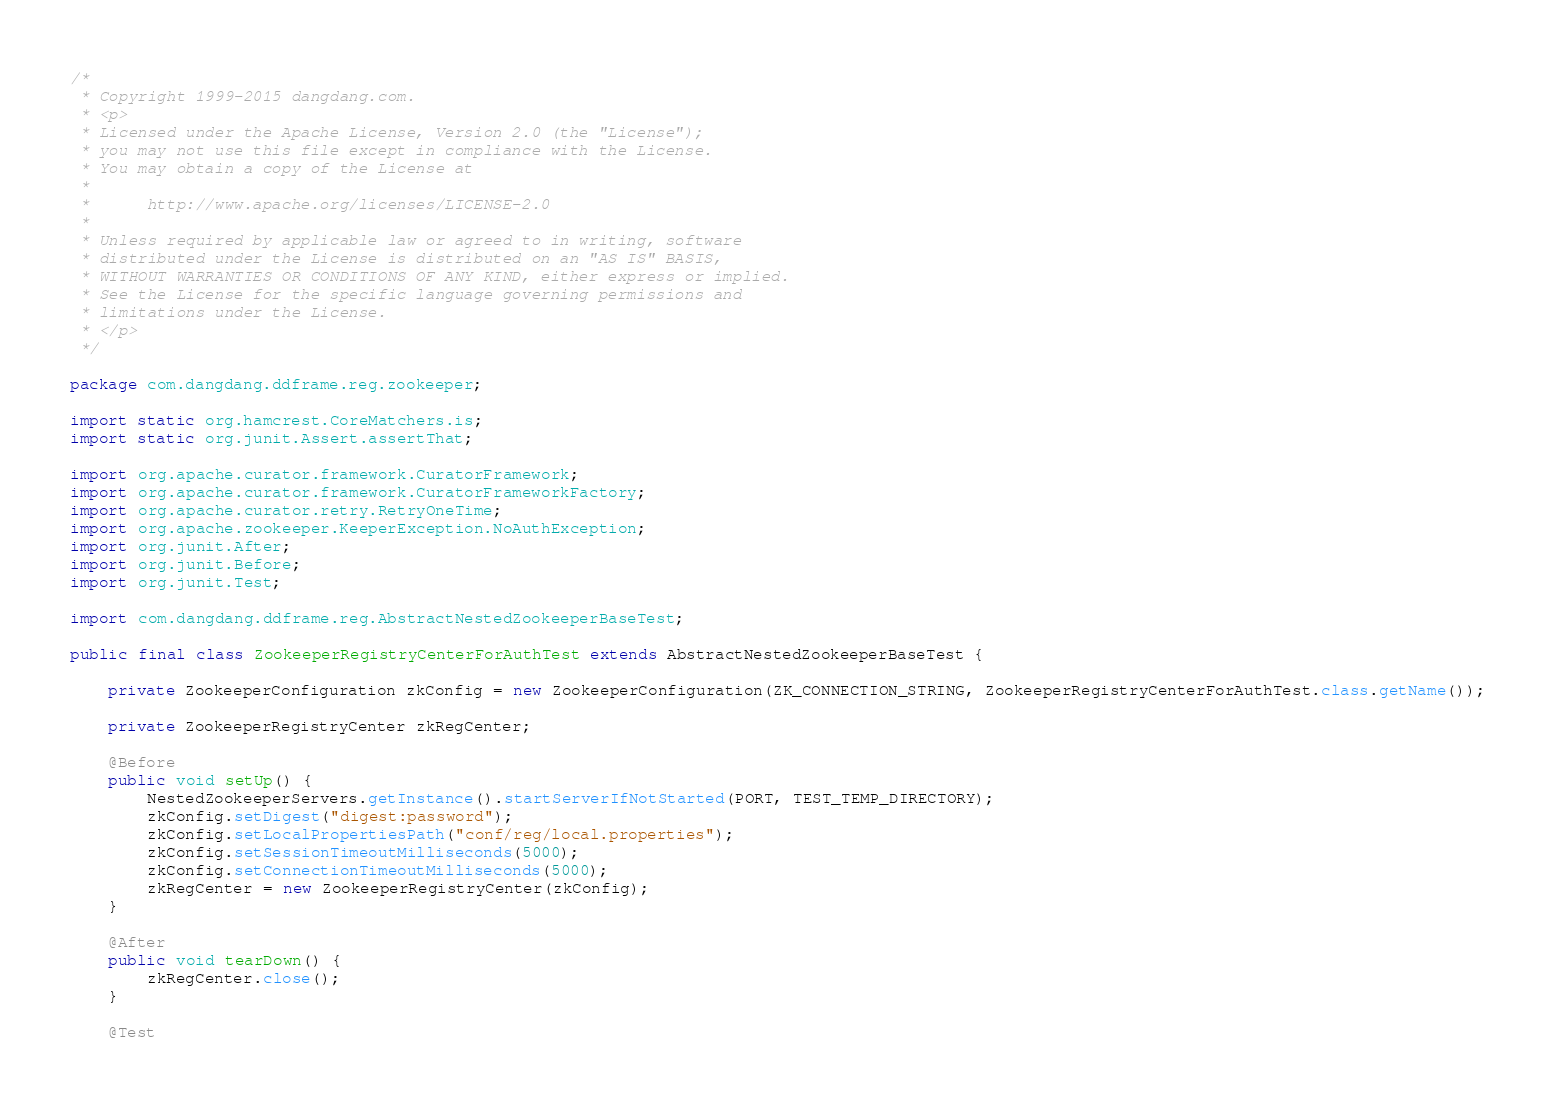<code> <loc_0><loc_0><loc_500><loc_500><_Java_>/*
 * Copyright 1999-2015 dangdang.com.
 * <p>
 * Licensed under the Apache License, Version 2.0 (the "License");
 * you may not use this file except in compliance with the License.
 * You may obtain a copy of the License at
 * 
 *      http://www.apache.org/licenses/LICENSE-2.0
 * 
 * Unless required by applicable law or agreed to in writing, software
 * distributed under the License is distributed on an "AS IS" BASIS,
 * WITHOUT WARRANTIES OR CONDITIONS OF ANY KIND, either express or implied.
 * See the License for the specific language governing permissions and
 * limitations under the License.
 * </p>
 */

package com.dangdang.ddframe.reg.zookeeper;

import static org.hamcrest.CoreMatchers.is;
import static org.junit.Assert.assertThat;

import org.apache.curator.framework.CuratorFramework;
import org.apache.curator.framework.CuratorFrameworkFactory;
import org.apache.curator.retry.RetryOneTime;
import org.apache.zookeeper.KeeperException.NoAuthException;
import org.junit.After;
import org.junit.Before;
import org.junit.Test;

import com.dangdang.ddframe.reg.AbstractNestedZookeeperBaseTest;

public final class ZookeeperRegistryCenterForAuthTest extends AbstractNestedZookeeperBaseTest {
    
    private ZookeeperConfiguration zkConfig = new ZookeeperConfiguration(ZK_CONNECTION_STRING, ZookeeperRegistryCenterForAuthTest.class.getName());
    
    private ZookeeperRegistryCenter zkRegCenter;
    
    @Before
    public void setUp() {
        NestedZookeeperServers.getInstance().startServerIfNotStarted(PORT, TEST_TEMP_DIRECTORY);
        zkConfig.setDigest("digest:password");
        zkConfig.setLocalPropertiesPath("conf/reg/local.properties");
        zkConfig.setSessionTimeoutMilliseconds(5000);
        zkConfig.setConnectionTimeoutMilliseconds(5000);
        zkRegCenter = new ZookeeperRegistryCenter(zkConfig);
    }
    
    @After
    public void tearDown() {
        zkRegCenter.close();
    }
    
    @Test</code> 